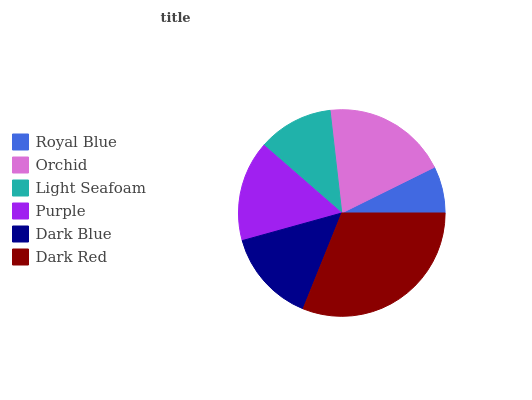Is Royal Blue the minimum?
Answer yes or no. Yes. Is Dark Red the maximum?
Answer yes or no. Yes. Is Orchid the minimum?
Answer yes or no. No. Is Orchid the maximum?
Answer yes or no. No. Is Orchid greater than Royal Blue?
Answer yes or no. Yes. Is Royal Blue less than Orchid?
Answer yes or no. Yes. Is Royal Blue greater than Orchid?
Answer yes or no. No. Is Orchid less than Royal Blue?
Answer yes or no. No. Is Purple the high median?
Answer yes or no. Yes. Is Dark Blue the low median?
Answer yes or no. Yes. Is Light Seafoam the high median?
Answer yes or no. No. Is Royal Blue the low median?
Answer yes or no. No. 